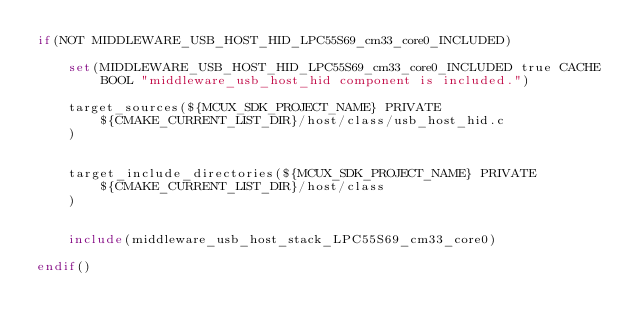<code> <loc_0><loc_0><loc_500><loc_500><_CMake_>if(NOT MIDDLEWARE_USB_HOST_HID_LPC55S69_cm33_core0_INCLUDED)
    
    set(MIDDLEWARE_USB_HOST_HID_LPC55S69_cm33_core0_INCLUDED true CACHE BOOL "middleware_usb_host_hid component is included.")

    target_sources(${MCUX_SDK_PROJECT_NAME} PRIVATE
        ${CMAKE_CURRENT_LIST_DIR}/host/class/usb_host_hid.c
    )


    target_include_directories(${MCUX_SDK_PROJECT_NAME} PRIVATE
        ${CMAKE_CURRENT_LIST_DIR}/host/class
    )


    include(middleware_usb_host_stack_LPC55S69_cm33_core0)

endif()
</code> 